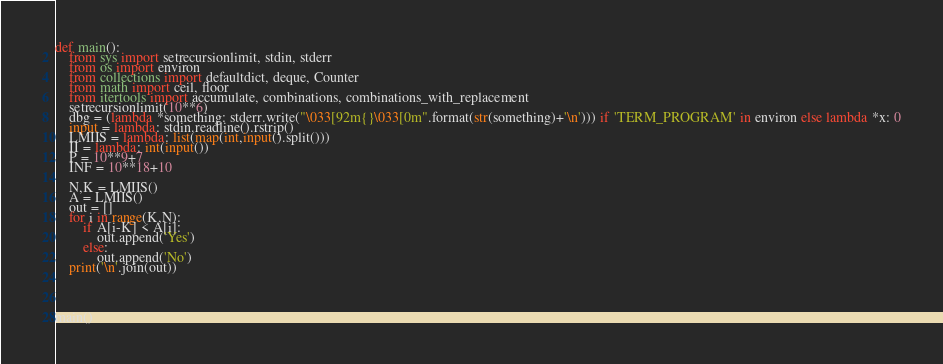<code> <loc_0><loc_0><loc_500><loc_500><_Python_>def main():
    from sys import setrecursionlimit, stdin, stderr
    from os import environ
    from collections import defaultdict, deque, Counter
    from math import ceil, floor
    from itertools import accumulate, combinations, combinations_with_replacement
    setrecursionlimit(10**6)
    dbg = (lambda *something: stderr.write("\033[92m{}\033[0m".format(str(something)+'\n'))) if 'TERM_PROGRAM' in environ else lambda *x: 0
    input = lambda: stdin.readline().rstrip()
    LMIIS = lambda: list(map(int,input().split()))
    II = lambda: int(input())
    P = 10**9+7
    INF = 10**18+10

    N,K = LMIIS()
    A = LMIIS()
    out = []
    for i in range(K,N):
        if A[i-K] < A[i]:
            out.append('Yes')
        else:
            out.append('No')
    print('\n'.join(out))



    
main()</code> 